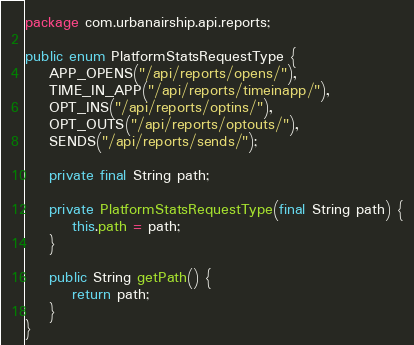<code> <loc_0><loc_0><loc_500><loc_500><_Java_>package com.urbanairship.api.reports;

public enum PlatformStatsRequestType {
    APP_OPENS("/api/reports/opens/"),
    TIME_IN_APP("/api/reports/timeinapp/"),
    OPT_INS("/api/reports/optins/"),
    OPT_OUTS("/api/reports/optouts/"),
    SENDS("/api/reports/sends/");

    private final String path;

    private PlatformStatsRequestType(final String path) {
        this.path = path;
    }

    public String getPath() {
        return path;
    }
}
</code> 